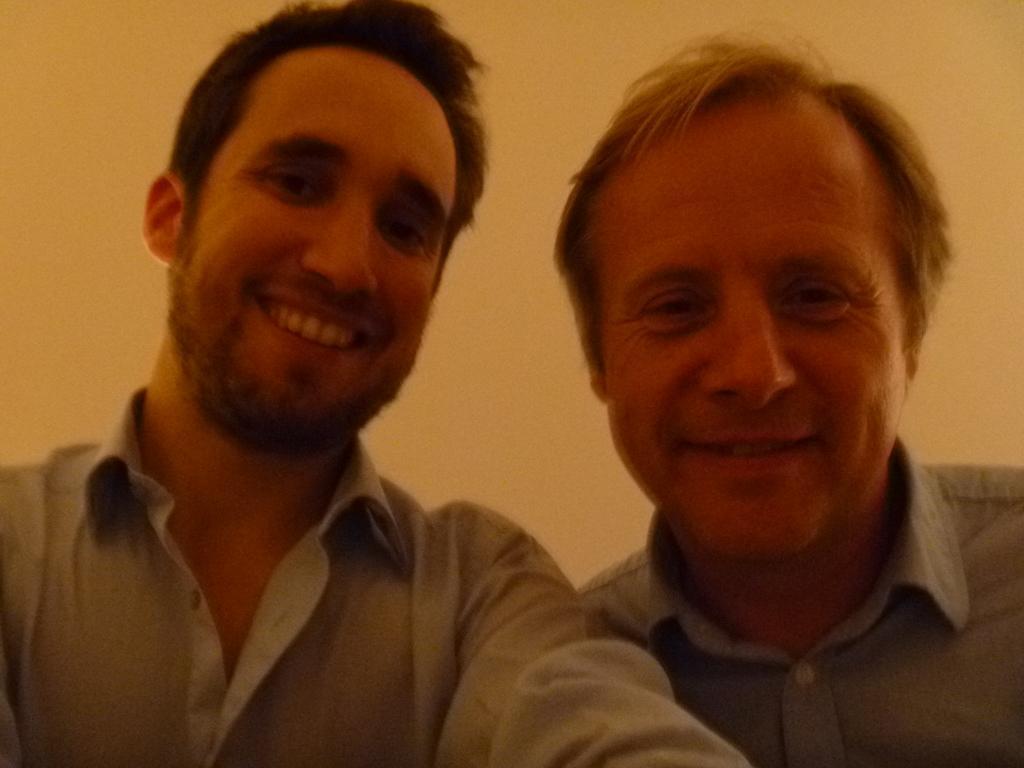How would you summarize this image in a sentence or two? In this image there are two men posing for the camera with a smile on their face. 